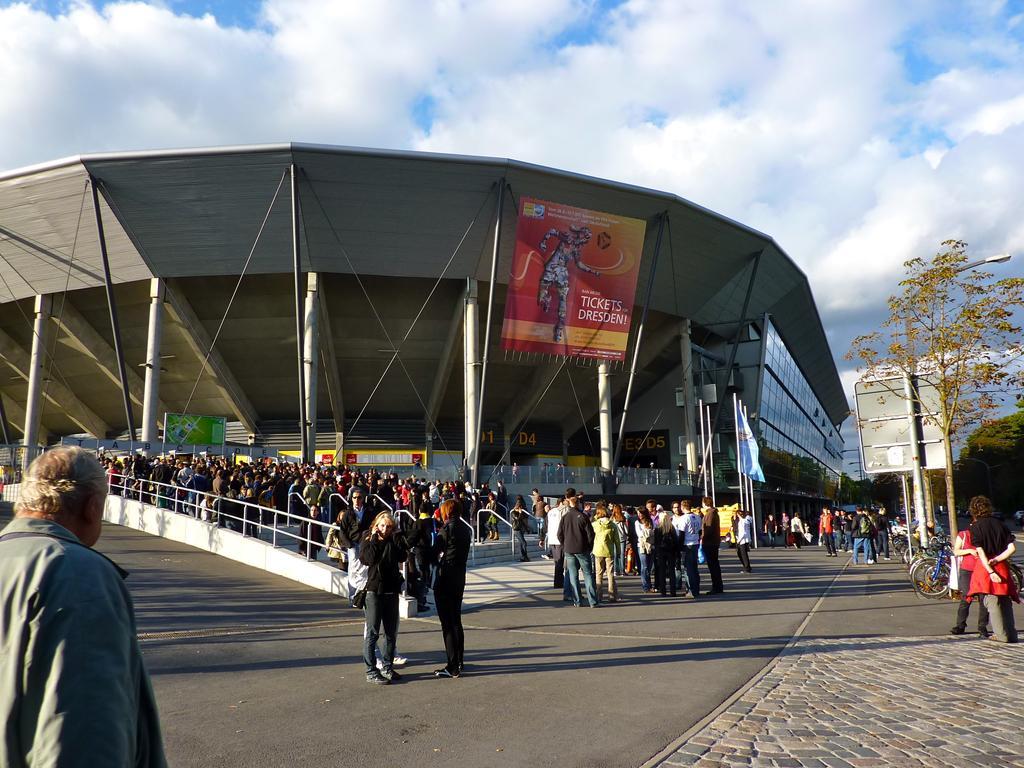Describe this image in one or two sentences. In this image we can see some people and there is a building which looks like a stadium and we can see a banner with some text attached to it. We can see a few flags in front of the building and there are some bicycles and on the right side of the image we can see some trees and there is a pole with the board. At the top we can see the sky with clouds. 